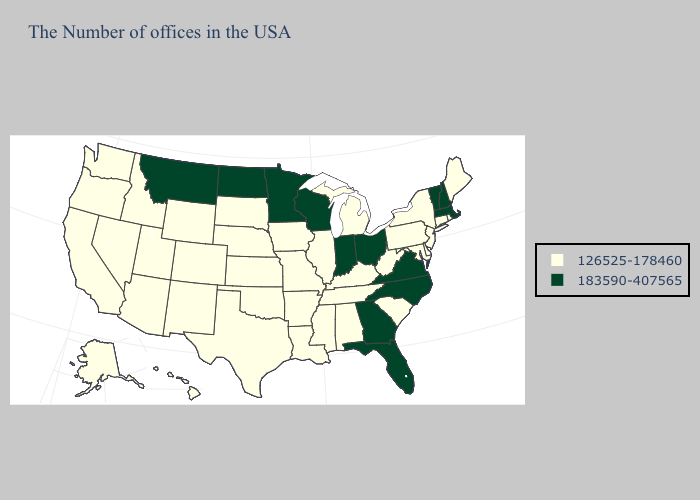What is the lowest value in the USA?
Keep it brief. 126525-178460. Which states have the lowest value in the West?
Be succinct. Wyoming, Colorado, New Mexico, Utah, Arizona, Idaho, Nevada, California, Washington, Oregon, Alaska, Hawaii. What is the highest value in the Northeast ?
Concise answer only. 183590-407565. Name the states that have a value in the range 183590-407565?
Be succinct. Massachusetts, New Hampshire, Vermont, Virginia, North Carolina, Ohio, Florida, Georgia, Indiana, Wisconsin, Minnesota, North Dakota, Montana. Does California have a lower value than Pennsylvania?
Quick response, please. No. Which states have the lowest value in the USA?
Keep it brief. Maine, Rhode Island, Connecticut, New York, New Jersey, Delaware, Maryland, Pennsylvania, South Carolina, West Virginia, Michigan, Kentucky, Alabama, Tennessee, Illinois, Mississippi, Louisiana, Missouri, Arkansas, Iowa, Kansas, Nebraska, Oklahoma, Texas, South Dakota, Wyoming, Colorado, New Mexico, Utah, Arizona, Idaho, Nevada, California, Washington, Oregon, Alaska, Hawaii. Does Washington have a higher value than Idaho?
Give a very brief answer. No. Which states hav the highest value in the Northeast?
Short answer required. Massachusetts, New Hampshire, Vermont. Which states have the lowest value in the USA?
Quick response, please. Maine, Rhode Island, Connecticut, New York, New Jersey, Delaware, Maryland, Pennsylvania, South Carolina, West Virginia, Michigan, Kentucky, Alabama, Tennessee, Illinois, Mississippi, Louisiana, Missouri, Arkansas, Iowa, Kansas, Nebraska, Oklahoma, Texas, South Dakota, Wyoming, Colorado, New Mexico, Utah, Arizona, Idaho, Nevada, California, Washington, Oregon, Alaska, Hawaii. Does the first symbol in the legend represent the smallest category?
Keep it brief. Yes. What is the value of South Dakota?
Give a very brief answer. 126525-178460. Name the states that have a value in the range 126525-178460?
Quick response, please. Maine, Rhode Island, Connecticut, New York, New Jersey, Delaware, Maryland, Pennsylvania, South Carolina, West Virginia, Michigan, Kentucky, Alabama, Tennessee, Illinois, Mississippi, Louisiana, Missouri, Arkansas, Iowa, Kansas, Nebraska, Oklahoma, Texas, South Dakota, Wyoming, Colorado, New Mexico, Utah, Arizona, Idaho, Nevada, California, Washington, Oregon, Alaska, Hawaii. What is the lowest value in states that border Arkansas?
Quick response, please. 126525-178460. What is the value of Utah?
Give a very brief answer. 126525-178460. 